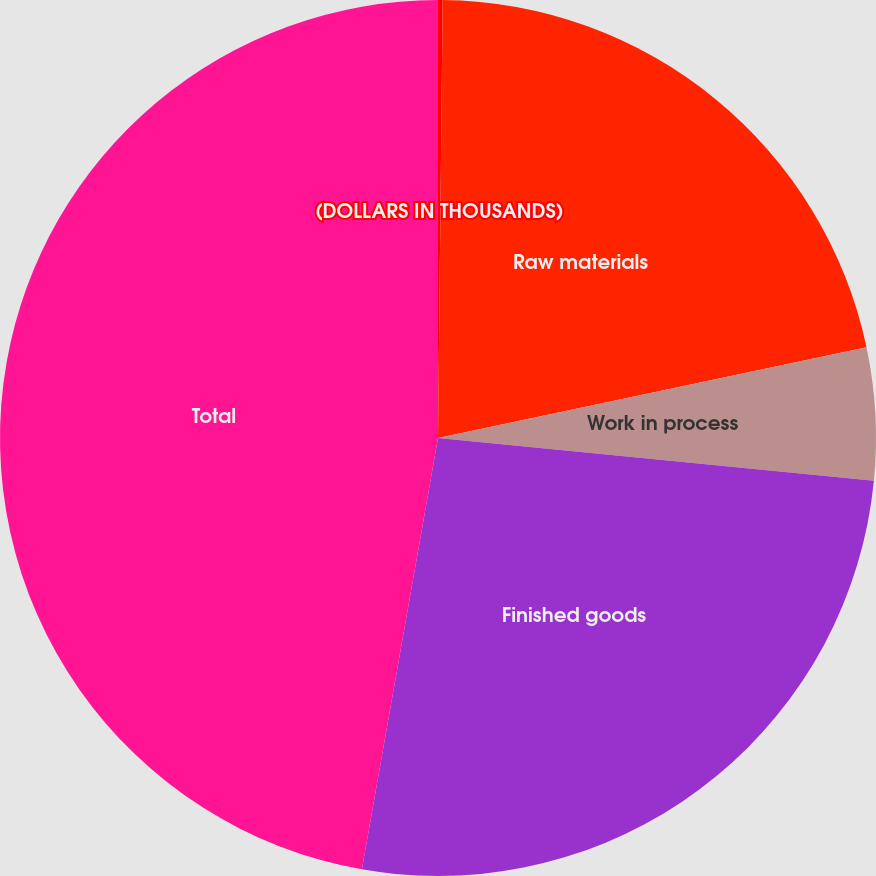Convert chart to OTSL. <chart><loc_0><loc_0><loc_500><loc_500><pie_chart><fcel>(DOLLARS IN THOUSANDS)<fcel>Raw materials<fcel>Work in process<fcel>Finished goods<fcel>Total<nl><fcel>0.17%<fcel>21.51%<fcel>4.88%<fcel>26.22%<fcel>47.22%<nl></chart> 